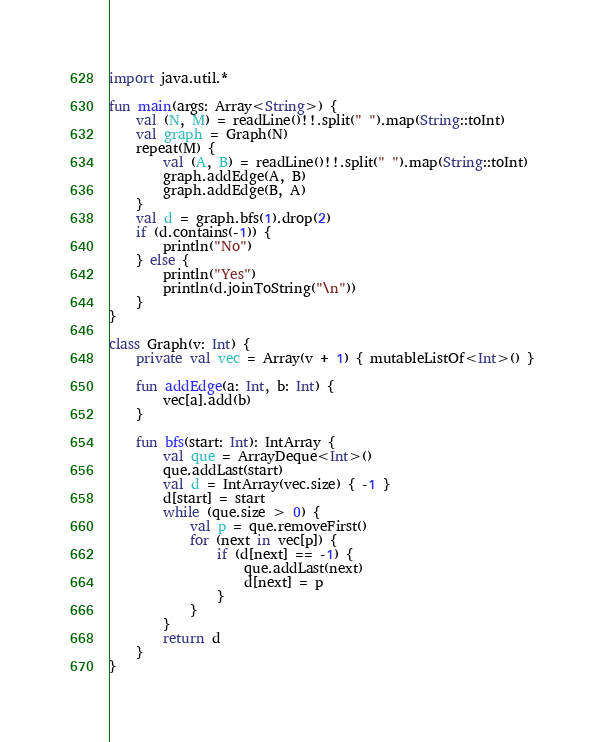<code> <loc_0><loc_0><loc_500><loc_500><_Kotlin_>import java.util.*

fun main(args: Array<String>) {
    val (N, M) = readLine()!!.split(" ").map(String::toInt)
    val graph = Graph(N)
    repeat(M) {
        val (A, B) = readLine()!!.split(" ").map(String::toInt)
        graph.addEdge(A, B)
        graph.addEdge(B, A)
    }
    val d = graph.bfs(1).drop(2)
    if (d.contains(-1)) {
        println("No")
    } else {
        println("Yes")
        println(d.joinToString("\n"))
    }
}

class Graph(v: Int) {
    private val vec = Array(v + 1) { mutableListOf<Int>() }

    fun addEdge(a: Int, b: Int) {
        vec[a].add(b)
    }

    fun bfs(start: Int): IntArray {
        val que = ArrayDeque<Int>()
        que.addLast(start)
        val d = IntArray(vec.size) { -1 }
        d[start] = start
        while (que.size > 0) {
            val p = que.removeFirst()
            for (next in vec[p]) {
                if (d[next] == -1) {
                    que.addLast(next)
                    d[next] = p
                }
            }
        }
        return d
    }
}</code> 